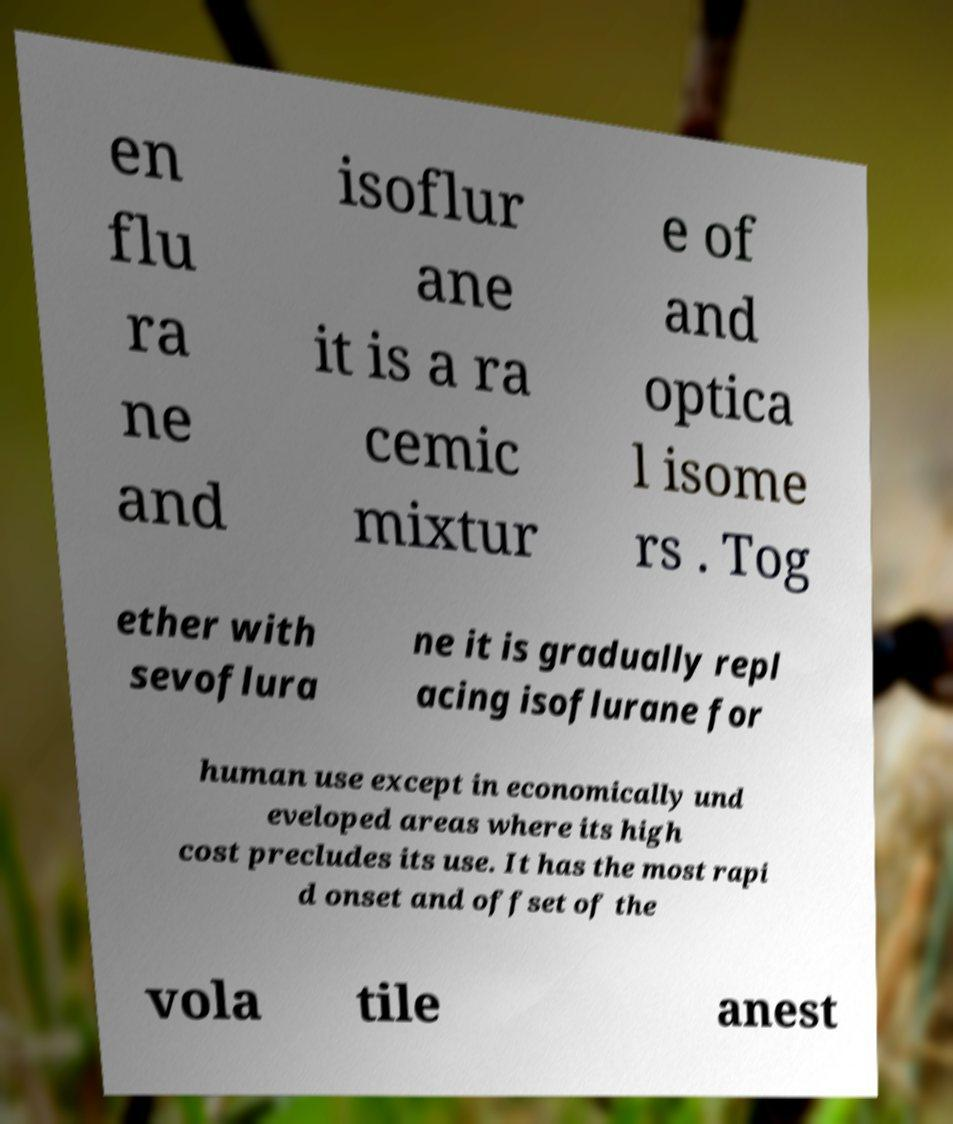There's text embedded in this image that I need extracted. Can you transcribe it verbatim? en flu ra ne and isoflur ane it is a ra cemic mixtur e of and optica l isome rs . Tog ether with sevoflura ne it is gradually repl acing isoflurane for human use except in economically und eveloped areas where its high cost precludes its use. It has the most rapi d onset and offset of the vola tile anest 